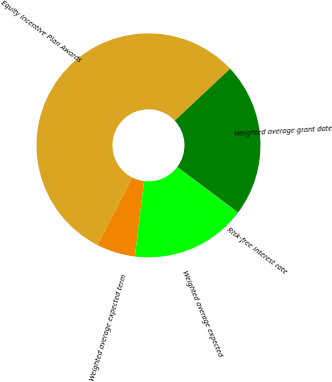Convert chart. <chart><loc_0><loc_0><loc_500><loc_500><pie_chart><fcel>Equity Incentive Plan Awards<fcel>Weighted average expected term<fcel>Weighted average expected<fcel>Risk-free interest rate<fcel>Weighted average grant date<nl><fcel>55.49%<fcel>5.58%<fcel>16.67%<fcel>0.04%<fcel>22.22%<nl></chart> 